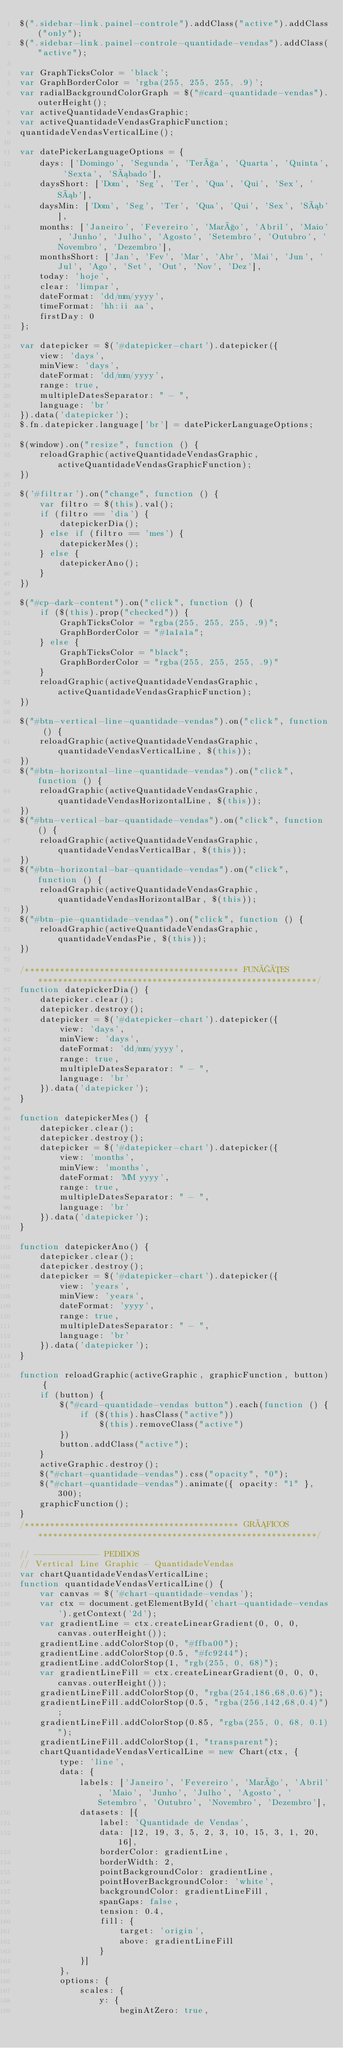Convert code to text. <code><loc_0><loc_0><loc_500><loc_500><_JavaScript_>$(".sidebar-link.painel-controle").addClass("active").addClass("only");
$(".sidebar-link.painel-controle-quantidade-vendas").addClass("active");

var GraphTicksColor = 'black';
var GraphBorderColor = 'rgba(255, 255, 255, .9)';
var radialBackgroundColorGraph = $("#card-quantidade-vendas").outerHeight();
var activeQuantidadeVendasGraphic;
var activeQuantidadeVendasGraphicFunction;
quantidadeVendasVerticalLine();

var datePickerLanguageOptions = {
    days: ['Domingo', 'Segunda', 'Terça', 'Quarta', 'Quinta', 'Sexta', 'Sábado'],
    daysShort: ['Dom', 'Seg', 'Ter', 'Qua', 'Qui', 'Sex', 'Sáb'],
    daysMin: ['Dom', 'Seg', 'Ter', 'Qua', 'Qui', 'Sex', 'Sáb'],
    months: ['Janeiro', 'Fevereiro', 'Março', 'Abril', 'Maio', 'Junho', 'Julho', 'Agosto', 'Setembro', 'Outubro', 'Novembro', 'Dezembro'],
    monthsShort: ['Jan', 'Fev', 'Mar', 'Abr', 'Mai', 'Jun', 'Jul', 'Ago', 'Set', 'Out', 'Nov', 'Dez'],
    today: 'hoje',
    clear: 'limpar',
    dateFormat: 'dd/mm/yyyy',
    timeFormat: 'hh:ii aa',
    firstDay: 0
};

var datepicker = $('#datepicker-chart').datepicker({
    view: 'days',
    minView: 'days',
    dateFormat: 'dd/mm/yyyy',
    range: true,
    multipleDatesSeparator: " - ",
    language: 'br'
}).data('datepicker');
$.fn.datepicker.language['br'] = datePickerLanguageOptions;

$(window).on("resize", function () {
    reloadGraphic(activeQuantidadeVendasGraphic, activeQuantidadeVendasGraphicFunction);
})

$('#filtrar').on("change", function () {
    var filtro = $(this).val();
    if (filtro == 'dia') {
        datepickerDia();
    } else if (filtro == 'mes') {
        datepickerMes();
    } else {
        datepickerAno();
    }
})

$("#cp-dark-content").on("click", function () {
    if ($(this).prop("checked")) {
        GraphTicksColor = "rgba(255, 255, 255, .9)";
        GraphBorderColor = "#1a1a1a";
    } else {
        GraphTicksColor = "black";
        GraphBorderColor = "rgba(255, 255, 255, .9)"
    }
    reloadGraphic(activeQuantidadeVendasGraphic, activeQuantidadeVendasGraphicFunction);
})

$("#btn-vertical-line-quantidade-vendas").on("click", function () {
    reloadGraphic(activeQuantidadeVendasGraphic, quantidadeVendasVerticalLine, $(this));
})
$("#btn-horizontal-line-quantidade-vendas").on("click", function () {
    reloadGraphic(activeQuantidadeVendasGraphic, quantidadeVendasHorizontalLine, $(this));
})
$("#btn-vertical-bar-quantidade-vendas").on("click", function () {
    reloadGraphic(activeQuantidadeVendasGraphic, quantidadeVendasVerticalBar, $(this));
})
$("#btn-horizontal-bar-quantidade-vendas").on("click", function () {
    reloadGraphic(activeQuantidadeVendasGraphic, quantidadeVendasHorizontalBar, $(this));
})
$("#btn-pie-quantidade-vendas").on("click", function () {
    reloadGraphic(activeQuantidadeVendasGraphic, quantidadeVendasPie, $(this));
})

/******************************************* FUNÇÕES ********************************************************/
function datepickerDia() {
    datepicker.clear();
    datepicker.destroy();
    datepicker = $('#datepicker-chart').datepicker({
        view: 'days',
        minView: 'days',
        dateFormat: 'dd/mm/yyyy',
        range: true,
        multipleDatesSeparator: " - ",
        language: 'br'
    }).data('datepicker');
}

function datepickerMes() {
    datepicker.clear();
    datepicker.destroy();
    datepicker = $('#datepicker-chart').datepicker({
        view: 'months',
        minView: 'months',
        dateFormat: 'MM yyyy',
        range: true,
        multipleDatesSeparator: " - ",
        language: 'br'
    }).data('datepicker');
}

function datepickerAno() {
    datepicker.clear();
    datepicker.destroy();
    datepicker = $('#datepicker-chart').datepicker({
        view: 'years',
        minView: 'years',
        dateFormat: 'yyyy',
        range: true,
        multipleDatesSeparator: " - ",
        language: 'br'
    }).data('datepicker');
}

function reloadGraphic(activeGraphic, graphicFunction, button) {
    if (button) {
        $("#card-quantidade-vendas button").each(function () {
            if ($(this).hasClass("active"))
                $(this).removeClass("active")
        })
        button.addClass("active");
    }
    activeGraphic.destroy();
    $("#chart-quantidade-vendas").css("opacity", "0");
    $("#chart-quantidade-vendas").animate({ opacity: "1" }, 300);
    graphicFunction();
}
/******************************************* GRÁFICOS ********************************************************/

// ------------- PEDIDOS
// Vertical Line Graphic - QuantidadeVendas
var chartQuantidadeVendasVerticalLine;
function quantidadeVendasVerticalLine() {
    var canvas = $('#chart-quantidade-vendas');
    var ctx = document.getElementById('chart-quantidade-vendas').getContext('2d');
    var gradientLine = ctx.createLinearGradient(0, 0, 0, canvas.outerHeight());
    gradientLine.addColorStop(0, "#ffba00");
    gradientLine.addColorStop(0.5, "#fc9244");
    gradientLine.addColorStop(1, "rgb(255, 0, 68)");
    var gradientLineFill = ctx.createLinearGradient(0, 0, 0, canvas.outerHeight());
    gradientLineFill.addColorStop(0, "rgba(254,186,68,0.6)");
    gradientLineFill.addColorStop(0.5, "rgba(256,142,68,0.4)");
    gradientLineFill.addColorStop(0.85, "rgba(255, 0, 68, 0.1)");
    gradientLineFill.addColorStop(1, "transparent");
    chartQuantidadeVendasVerticalLine = new Chart(ctx, {
        type: 'line',
        data: {
            labels: ['Janeiro', 'Fevereiro', 'Março', 'Abril', 'Maio', 'Junho', 'Julho', 'Agosto', 'Setembro', 'Outubro', 'Novembro', 'Dezembro'],
            datasets: [{
                label: 'Quantidade de Vendas',
                data: [12, 19, 3, 5, 2, 3, 10, 15, 3, 1, 20, 16],
                borderColor: gradientLine,
                borderWidth: 2,
                pointBackgroundColor: gradientLine,
                pointHoverBackgroundColor: 'white',
                backgroundColor: gradientLineFill,
                spanGaps: false,
                tension: 0.4,
                fill: {
                    target: 'origin',
                    above: gradientLineFill
                }
            }]
        },
        options: {
            scales: {
                y: {
                    beginAtZero: true,</code> 